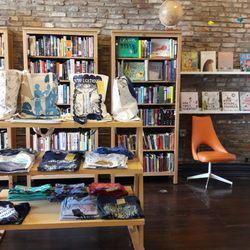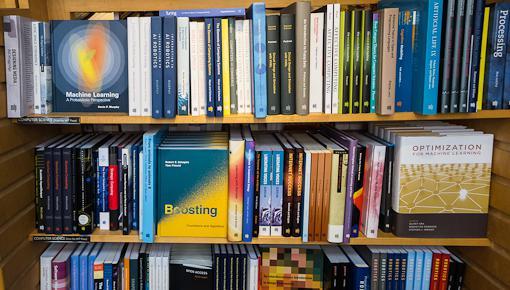The first image is the image on the left, the second image is the image on the right. Given the left and right images, does the statement "In at least one image there are three bookcase shelves facing foward." hold true? Answer yes or no. Yes. The first image is the image on the left, the second image is the image on the right. Analyze the images presented: Is the assertion "The right image shows no more than six shelves of books and no shelves have white labels on their edges." valid? Answer yes or no. Yes. 